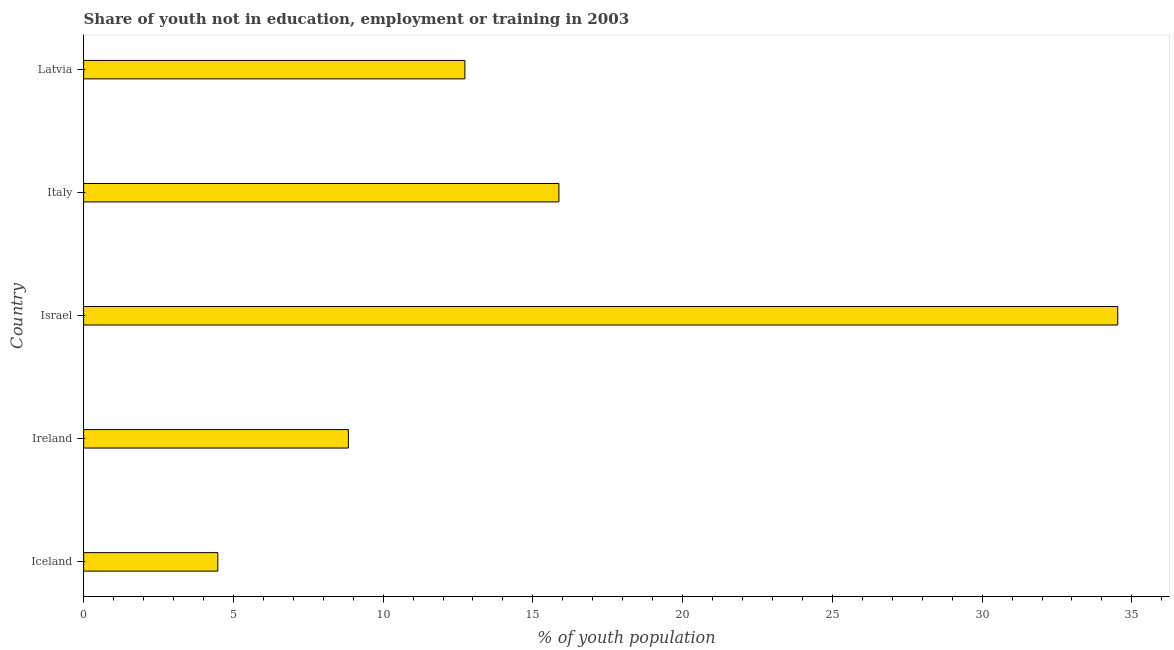What is the title of the graph?
Provide a short and direct response. Share of youth not in education, employment or training in 2003. What is the label or title of the X-axis?
Provide a succinct answer. % of youth population. What is the unemployed youth population in Israel?
Your answer should be compact. 34.53. Across all countries, what is the maximum unemployed youth population?
Your answer should be compact. 34.53. Across all countries, what is the minimum unemployed youth population?
Your answer should be compact. 4.48. In which country was the unemployed youth population maximum?
Offer a terse response. Israel. In which country was the unemployed youth population minimum?
Your answer should be compact. Iceland. What is the sum of the unemployed youth population?
Offer a terse response. 76.45. What is the difference between the unemployed youth population in Israel and Latvia?
Give a very brief answer. 21.8. What is the average unemployed youth population per country?
Provide a succinct answer. 15.29. What is the median unemployed youth population?
Your answer should be very brief. 12.73. What is the ratio of the unemployed youth population in Ireland to that in Israel?
Provide a succinct answer. 0.26. Is the unemployed youth population in Ireland less than that in Latvia?
Your answer should be very brief. Yes. Is the difference between the unemployed youth population in Ireland and Italy greater than the difference between any two countries?
Keep it short and to the point. No. What is the difference between the highest and the second highest unemployed youth population?
Offer a very short reply. 18.66. Is the sum of the unemployed youth population in Ireland and Israel greater than the maximum unemployed youth population across all countries?
Your answer should be compact. Yes. What is the difference between the highest and the lowest unemployed youth population?
Your answer should be compact. 30.05. Are the values on the major ticks of X-axis written in scientific E-notation?
Your answer should be very brief. No. What is the % of youth population of Iceland?
Offer a terse response. 4.48. What is the % of youth population in Ireland?
Your response must be concise. 8.84. What is the % of youth population in Israel?
Your answer should be compact. 34.53. What is the % of youth population in Italy?
Keep it short and to the point. 15.87. What is the % of youth population in Latvia?
Your answer should be compact. 12.73. What is the difference between the % of youth population in Iceland and Ireland?
Your response must be concise. -4.36. What is the difference between the % of youth population in Iceland and Israel?
Keep it short and to the point. -30.05. What is the difference between the % of youth population in Iceland and Italy?
Make the answer very short. -11.39. What is the difference between the % of youth population in Iceland and Latvia?
Offer a very short reply. -8.25. What is the difference between the % of youth population in Ireland and Israel?
Ensure brevity in your answer.  -25.69. What is the difference between the % of youth population in Ireland and Italy?
Offer a very short reply. -7.03. What is the difference between the % of youth population in Ireland and Latvia?
Ensure brevity in your answer.  -3.89. What is the difference between the % of youth population in Israel and Italy?
Your response must be concise. 18.66. What is the difference between the % of youth population in Israel and Latvia?
Provide a short and direct response. 21.8. What is the difference between the % of youth population in Italy and Latvia?
Your answer should be compact. 3.14. What is the ratio of the % of youth population in Iceland to that in Ireland?
Offer a terse response. 0.51. What is the ratio of the % of youth population in Iceland to that in Israel?
Give a very brief answer. 0.13. What is the ratio of the % of youth population in Iceland to that in Italy?
Your response must be concise. 0.28. What is the ratio of the % of youth population in Iceland to that in Latvia?
Ensure brevity in your answer.  0.35. What is the ratio of the % of youth population in Ireland to that in Israel?
Offer a terse response. 0.26. What is the ratio of the % of youth population in Ireland to that in Italy?
Provide a succinct answer. 0.56. What is the ratio of the % of youth population in Ireland to that in Latvia?
Offer a very short reply. 0.69. What is the ratio of the % of youth population in Israel to that in Italy?
Offer a terse response. 2.18. What is the ratio of the % of youth population in Israel to that in Latvia?
Your answer should be compact. 2.71. What is the ratio of the % of youth population in Italy to that in Latvia?
Ensure brevity in your answer.  1.25. 